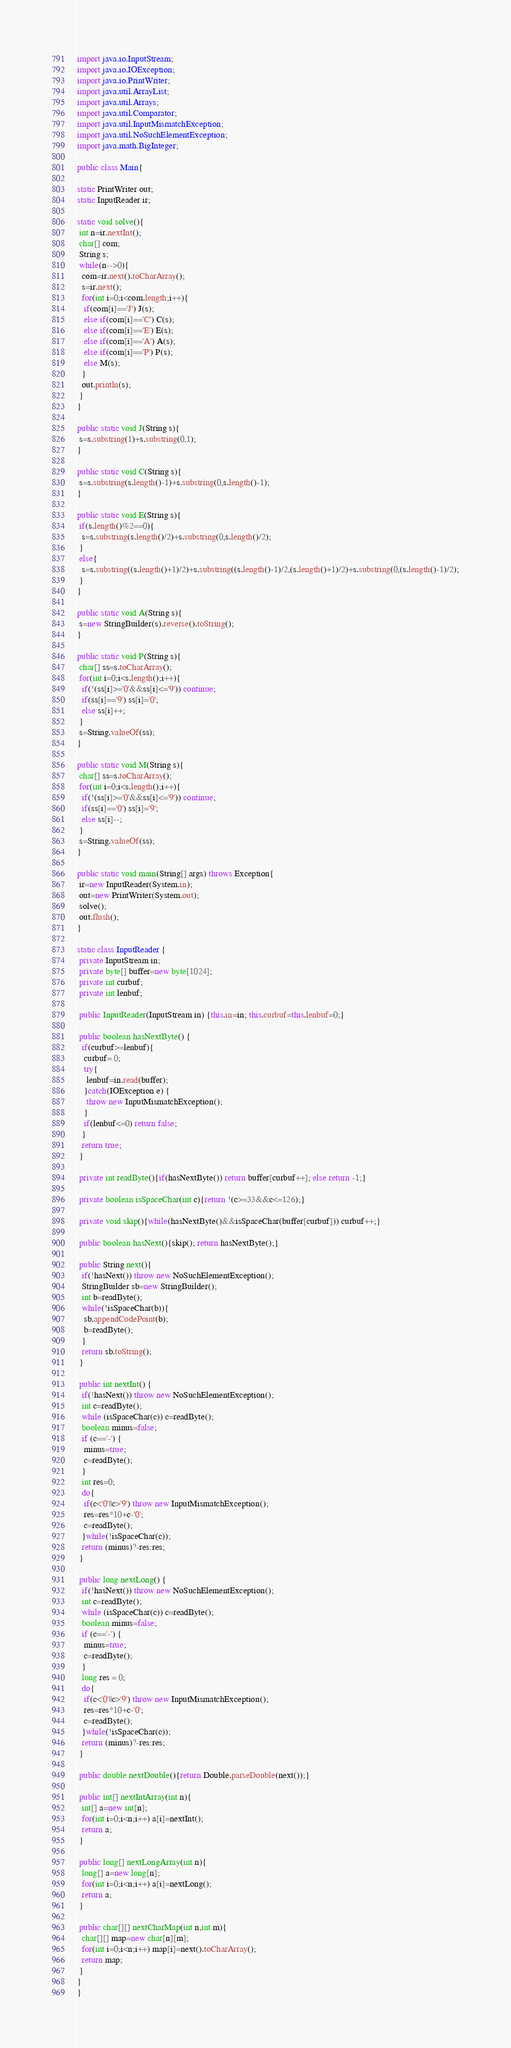<code> <loc_0><loc_0><loc_500><loc_500><_Java_>import java.io.InputStream;
import java.io.IOException;
import java.io.PrintWriter;
import java.util.ArrayList;
import java.util.Arrays;
import java.util.Comparator;
import java.util.InputMismatchException;
import java.util.NoSuchElementException;
import java.math.BigInteger;

public class Main{

static PrintWriter out;
static InputReader ir;

static void solve(){
 int n=ir.nextInt();
 char[] com;
 String s;
 while(n-->0){
  com=ir.next().toCharArray();
  s=ir.next();
  for(int i=0;i<com.length;i++){
   if(com[i]=='J') J(s);
   else if(com[i]=='C') C(s);
   else if(com[i]=='E') E(s);
   else if(com[i]=='A') A(s);
   else if(com[i]=='P') P(s);
   else M(s);
  }
  out.println(s);
 }
}

public static void J(String s){
 s=s.substring(1)+s.substring(0,1);
}

public static void C(String s){
 s=s.substring(s.length()-1)+s.substring(0,s.length()-1);
}

public static void E(String s){
 if(s.length()%2==0){
  s=s.substring(s.length()/2)+s.substring(0,s.length()/2);
 }
 else{
  s=s.substring((s.length()+1)/2)+s.substring((s.length()-1)/2,(s.length()+1)/2)+s.substring(0,(s.length()-1)/2);
 }
}

public static void A(String s){
 s=new StringBuilder(s).reverse().toString();
}

public static void P(String s){
 char[] ss=s.toCharArray();
 for(int i=0;i<s.length();i++){
  if(!(ss[i]>='0'&&ss[i]<='9')) continue;
  if(ss[i]=='9') ss[i]='0';
  else ss[i]++;
 }
 s=String.valueOf(ss);
}

public static void M(String s){
 char[] ss=s.toCharArray();
 for(int i=0;i<s.length();i++){
  if(!(ss[i]>='0'&&ss[i]<='9')) continue;
  if(ss[i]=='0') ss[i]='9';
  else ss[i]--;
 }
 s=String.valueOf(ss);
}

public static void main(String[] args) throws Exception{
 ir=new InputReader(System.in);
 out=new PrintWriter(System.out);
 solve();
 out.flush();
}

static class InputReader {
 private InputStream in;
 private byte[] buffer=new byte[1024];
 private int curbuf;
 private int lenbuf;

 public InputReader(InputStream in) {this.in=in; this.curbuf=this.lenbuf=0;}
 
 public boolean hasNextByte() {
  if(curbuf>=lenbuf){
   curbuf= 0;
   try{
    lenbuf=in.read(buffer);
   }catch(IOException e) {
    throw new InputMismatchException();
   }
   if(lenbuf<=0) return false;
  }
  return true;
 }

 private int readByte(){if(hasNextByte()) return buffer[curbuf++]; else return -1;}
 
 private boolean isSpaceChar(int c){return !(c>=33&&c<=126);}
 
 private void skip(){while(hasNextByte()&&isSpaceChar(buffer[curbuf])) curbuf++;}
 
 public boolean hasNext(){skip(); return hasNextByte();}
 
 public String next(){
  if(!hasNext()) throw new NoSuchElementException();
  StringBuilder sb=new StringBuilder();
  int b=readByte();
  while(!isSpaceChar(b)){
   sb.appendCodePoint(b);
   b=readByte();
  }
  return sb.toString();
 }
 
 public int nextInt() {
  if(!hasNext()) throw new NoSuchElementException();
  int c=readByte();
  while (isSpaceChar(c)) c=readByte();
  boolean minus=false;
  if (c=='-') {
   minus=true;
   c=readByte();
  }
  int res=0;
  do{
   if(c<'0'||c>'9') throw new InputMismatchException();
   res=res*10+c-'0';
   c=readByte();
  }while(!isSpaceChar(c));
  return (minus)?-res:res;
 }
 
 public long nextLong() {
  if(!hasNext()) throw new NoSuchElementException();
  int c=readByte();
  while (isSpaceChar(c)) c=readByte();
  boolean minus=false;
  if (c=='-') {
   minus=true;
   c=readByte();
  }
  long res = 0;
  do{
   if(c<'0'||c>'9') throw new InputMismatchException();
   res=res*10+c-'0';
   c=readByte();
  }while(!isSpaceChar(c));
  return (minus)?-res:res;
 }

 public double nextDouble(){return Double.parseDouble(next());}

 public int[] nextIntArray(int n){
  int[] a=new int[n];
  for(int i=0;i<n;i++) a[i]=nextInt();
  return a;
 }

 public long[] nextLongArray(int n){
  long[] a=new long[n];
  for(int i=0;i<n;i++) a[i]=nextLong();
  return a;
 }

 public char[][] nextCharMap(int n,int m){
  char[][] map=new char[n][m];
  for(int i=0;i<n;i++) map[i]=next().toCharArray();
  return map;
 }
}
}</code> 